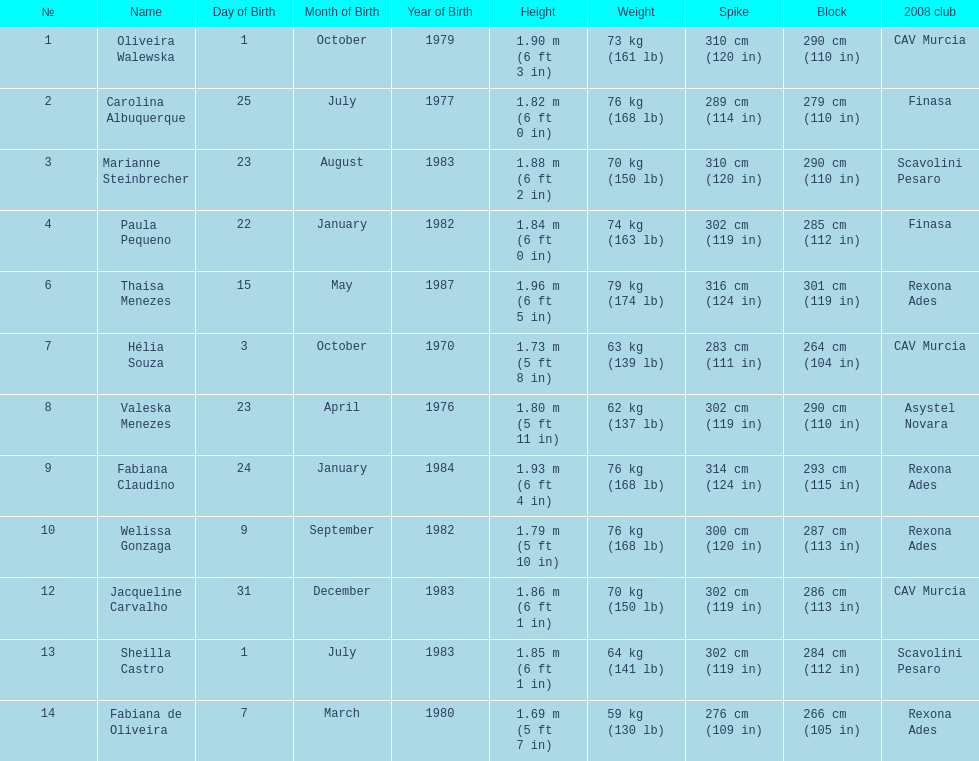Who is the next tallest player after thaisa menezes? Fabiana Claudino. 